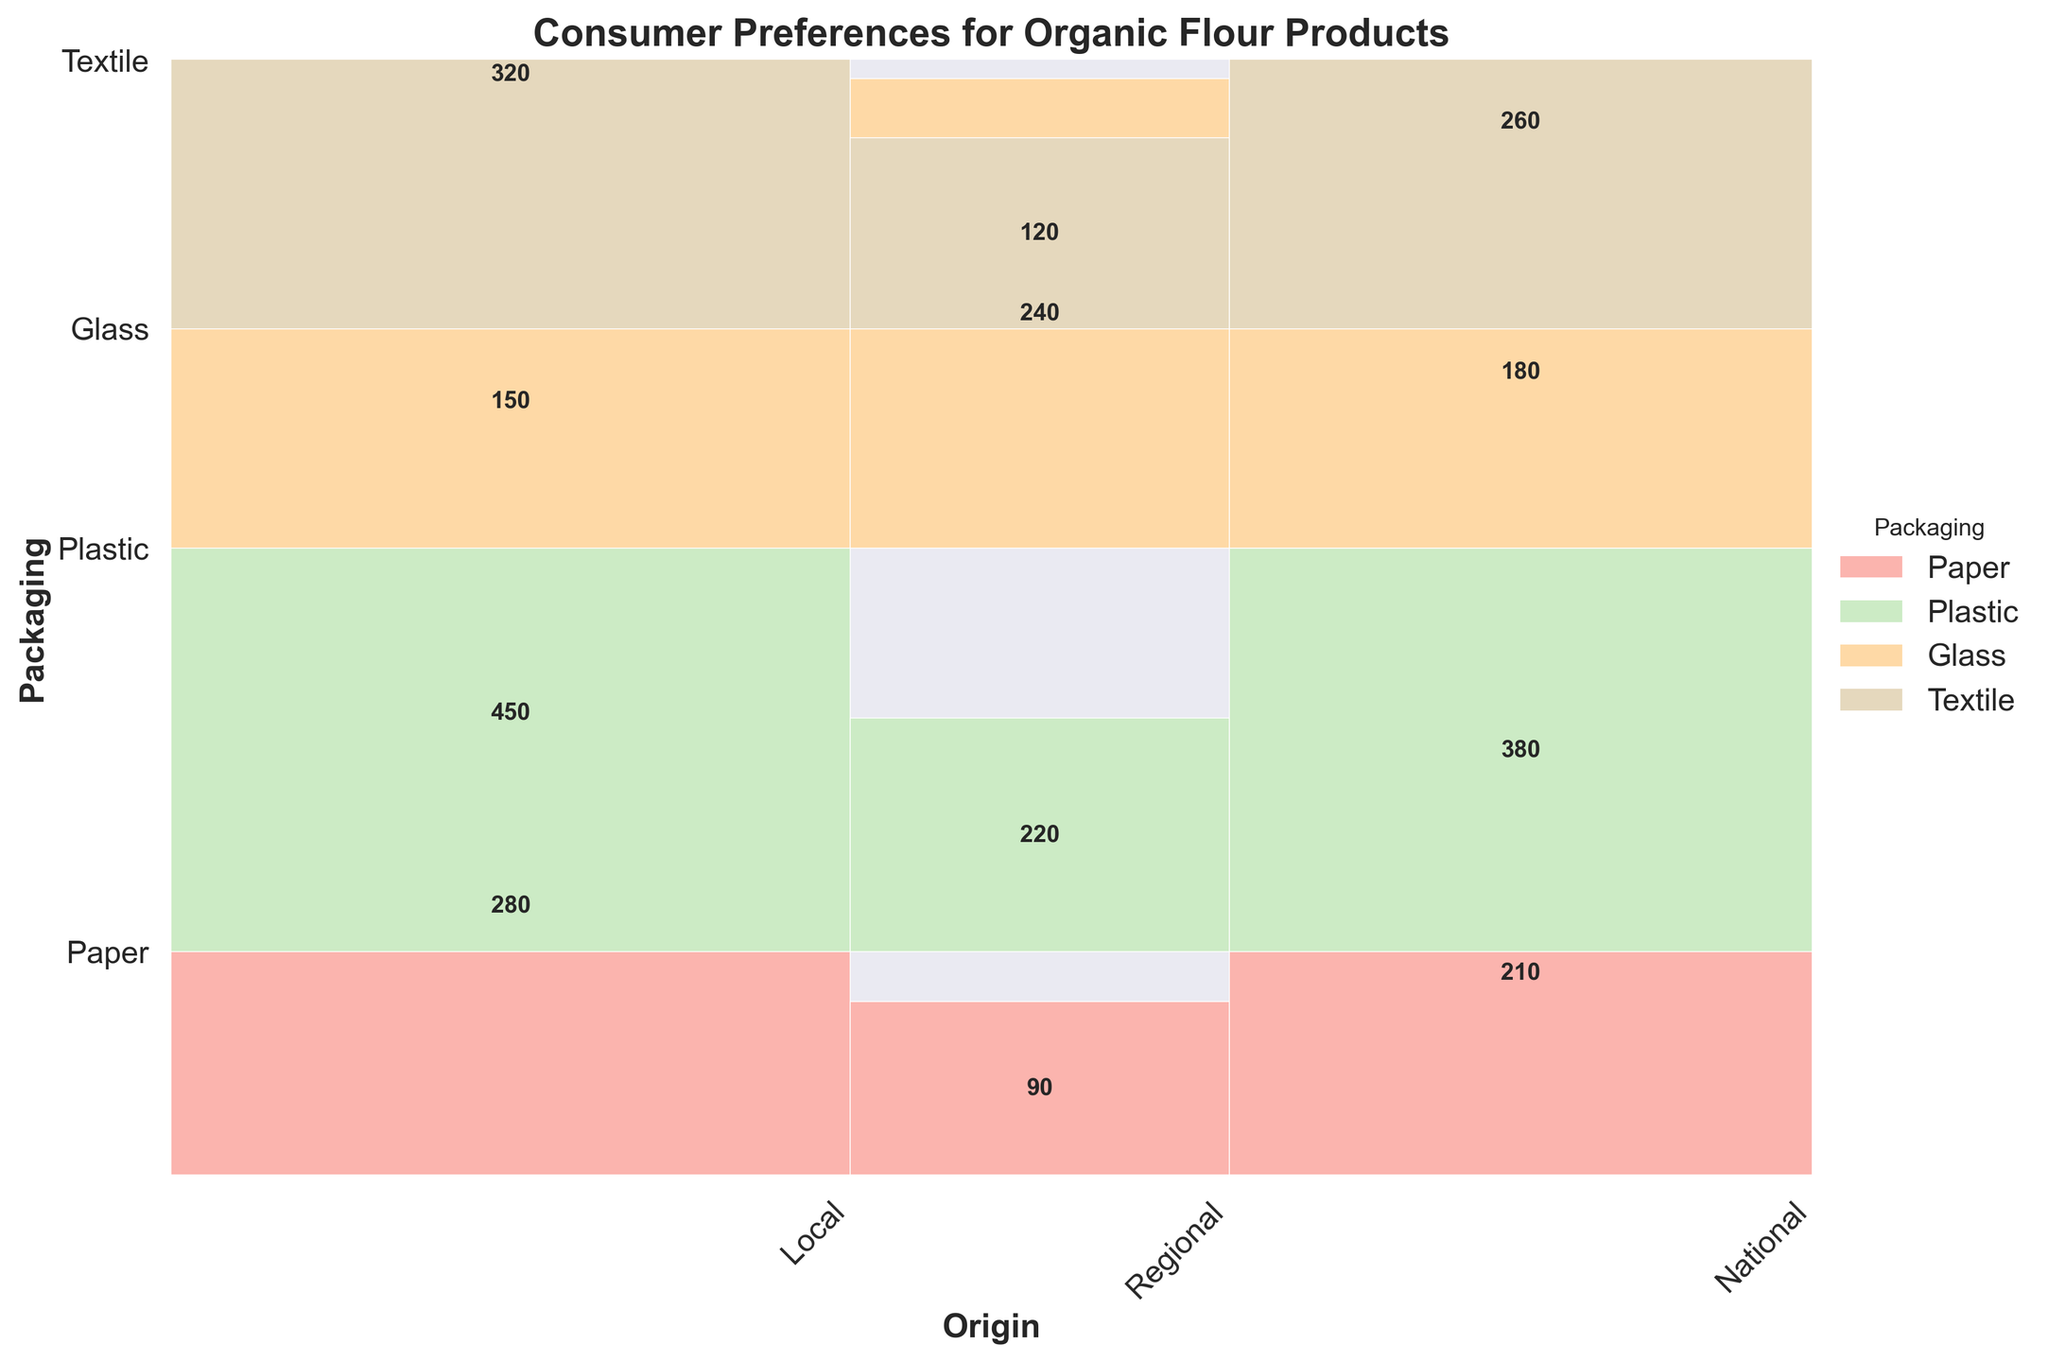What's the title of the figure? The title is displayed at the top of the figure and clearly states, "Consumer Preferences for Organic Flour Products."
Answer: Consumer Preferences for Organic Flour Products What's the packaging material with the highest consumer preference for local products? By looking at the section in the figure corresponding to local products, we can see that the paper section is the tallest, indicating the highest preference.
Answer: Paper Which origin has the least consumer preference for glass packaging? The bar representing national origin for glass packaging is the smallest, indicating the least preference.
Answer: National Which packaging material has the most balanced preference across all origins? Examining the heights of the sections across all origins, textile packaging has relatively similar-sized sections across local, regional, and national origins.
Answer: Textile How many more consumers prefer paper packaging over plastic for local products? From the figure, the height of the local section for paper packaging is about 450, while plastic is about 150. The difference is 450 - 150.
Answer: 300 What is the total preference for regional products across all packaging materials? By summing the regional preferences for all materials: Paper (380) + Plastic (180) + Glass (210) + Textile (260) = 1030.
Answer: 1030 Which packaging material shows the highest preference for national products? Observing the sections for national products, plastic has the tallest bar, indicating the highest preference.
Answer: Plastic What is the combined preference for local and regional paper packaging? Sum the local and regional preferences for paper packaging: 450 + 380 = 830.
Answer: 830 Does glass packaging have a higher preference for local products or regional products? The local preference section for glass packaging is taller than the regional section, indicating a higher preference for local.
Answer: Local What percentage do consumers prefer paper packaging for local products compared to the total preference for local products? The total local preference across all materials is the sum of the heights corresponding to local (450+150+280+320 = 1200). The percentage for paper is (450/1200) * 100.
Answer: 37.5% 